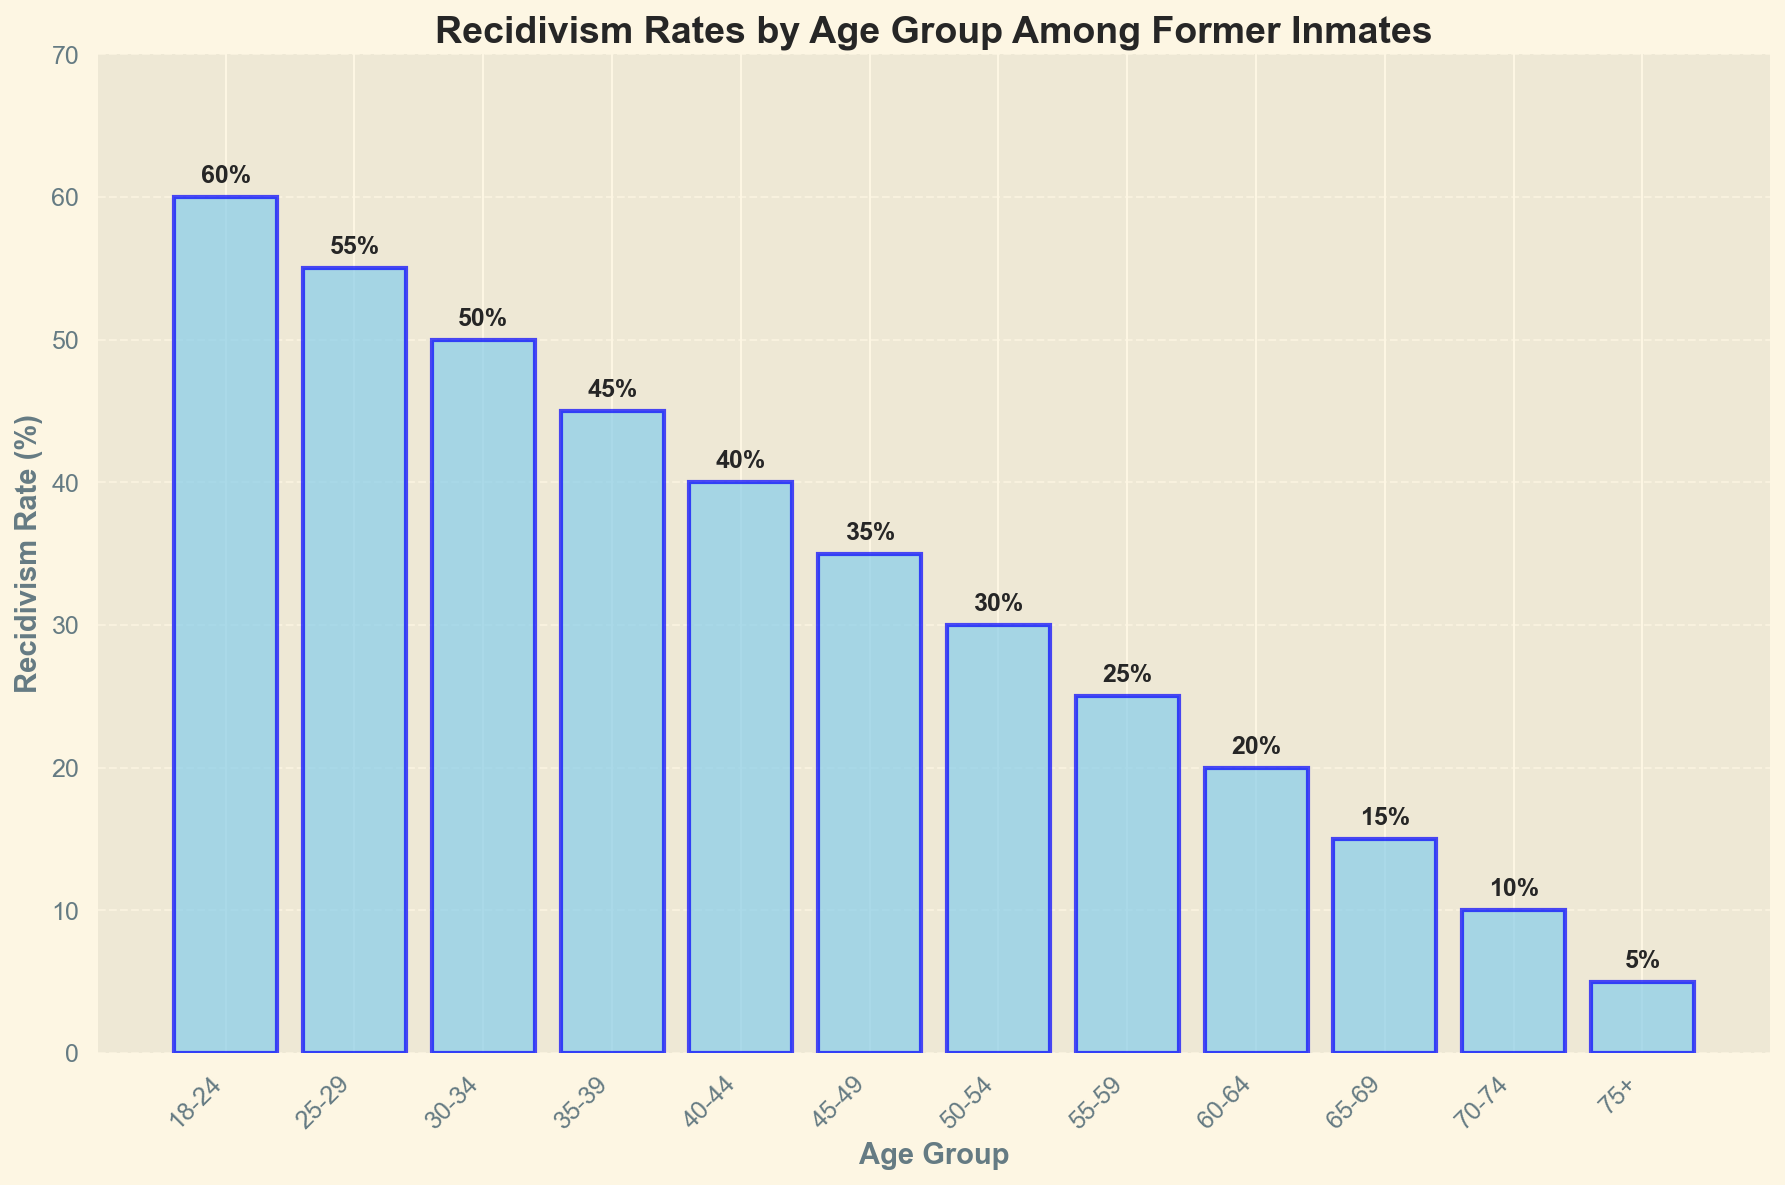What age group has the highest recidivism rate? The bar for age group 18-24 is the tallest in the histogram, indicating the highest recidivism rate.
Answer: 18-24 What age group has the lowest recidivism rate? The bar for age group 75+ is the shortest in the histogram, indicating the lowest recidivism rate.
Answer: 75+ Which age groups have a recidivism rate of at least 50%? The bars for age groups 18-24, 25-29, and 30-34 reach or surpass the 50% mark on the y-axis.
Answer: 18-24, 25-29, 30-34 What is the difference in recidivism rates between age groups 18-24 and 75+? The recidivism rate for age group 18-24 is 60%, and for age group 75+ is 5%. The difference is calculated as 60% - 5%.
Answer: 55% Which age group shows a recidivism rate of 35%? The bar for age group 45-49 reaches the 35% mark on the y-axis.
Answer: 45-49 How much higher is the recidivism rate of the age group 25-29 compared to the age group 50-54? The recidivism rate for age group 25-29 is 55%, and for age group 50-54 is 30%. The difference is calculated as 55% - 30%.
Answer: 25% What is the average recidivism rate for the 10-year age groups from 18-64? The recidivism rates for age groups 18-24 to 60-64 are (60, 55, 50, 45, 40, 35, 30, 25, 20). The average is calculated by summing these rates and dividing by 9. (60+55+50+45+40+35+30+25+20)/9 = 360/9 = 40
Answer: 40 What's the sum of recidivism rates of age groups 55-59 and 65-69? The recidivism rate for age group 55-59 is 25%, and for age group 65-69 is 15%. The sum is calculated as 25% + 15%.
Answer: 40% By how many percentage points does the recidivism rate decrease from age group 30-34 to age group 35-39? The recidivism rate for age group 30-34 is 50%, and for age group 35-39 is 45%. The decrease is calculated as 50% - 45%.
Answer: 5% What is the median recidivism rate among the age groups listed? The recidivism rates ordered from smallest to largest are (5, 10, 15, 20, 25, 30, 35, 40, 45, 50, 55, 60). The median is the average of the 6th and 7th numbers, as there are 12 total rates.
(30+35)/2 = 32.5
Answer: 32.5 